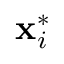Convert formula to latex. <formula><loc_0><loc_0><loc_500><loc_500>{ x } _ { i } ^ { * }</formula> 